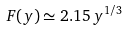Convert formula to latex. <formula><loc_0><loc_0><loc_500><loc_500>F ( y ) \simeq 2 . 1 5 \, y ^ { 1 / 3 }</formula> 